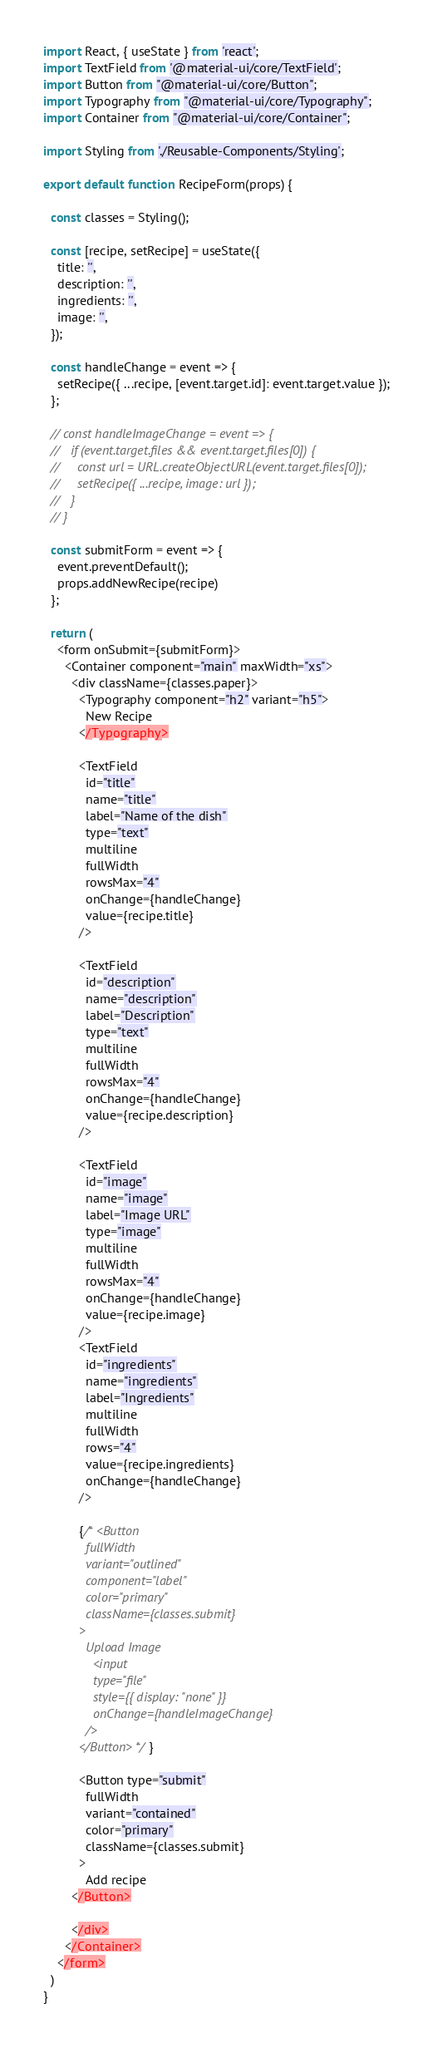Convert code to text. <code><loc_0><loc_0><loc_500><loc_500><_JavaScript_>import React, { useState } from 'react';
import TextField from '@material-ui/core/TextField';
import Button from "@material-ui/core/Button";
import Typography from "@material-ui/core/Typography";
import Container from "@material-ui/core/Container";

import Styling from './Reusable-Components/Styling';

export default function RecipeForm(props) {

  const classes = Styling();

  const [recipe, setRecipe] = useState({
    title: '',
    description: '',
    ingredients: '',
    image: '',
  });

  const handleChange = event => {
    setRecipe({ ...recipe, [event.target.id]: event.target.value });
  };

  // const handleImageChange = event => {
  //   if (event.target.files && event.target.files[0]) {
  //     const url = URL.createObjectURL(event.target.files[0]);
  //     setRecipe({ ...recipe, image: url });
  //   }
  // }

  const submitForm = event => {
    event.preventDefault();
    props.addNewRecipe(recipe)
  };

  return (
    <form onSubmit={submitForm}>
      <Container component="main" maxWidth="xs">
        <div className={classes.paper}>
          <Typography component="h2" variant="h5">
            New Recipe
          </Typography>

          <TextField
            id="title"
            name="title"
            label="Name of the dish"
            type="text"
            multiline
            fullWidth
            rowsMax="4"
            onChange={handleChange}
            value={recipe.title}
          />

          <TextField
            id="description"
            name="description"
            label="Description"
            type="text"
            multiline
            fullWidth
            rowsMax="4"
            onChange={handleChange}
            value={recipe.description}
          />

          <TextField
            id="image"
            name="image"
            label="Image URL"
            type="image"
            multiline
            fullWidth
            rowsMax="4"
            onChange={handleChange}
            value={recipe.image}
          />
          <TextField
            id="ingredients"
            name="ingredients"
            label="Ingredients"
            multiline
            fullWidth
            rows="4"
            value={recipe.ingredients}
            onChange={handleChange}
          />

          {/* <Button
            fullWidth
            variant="outlined"
            component="label"
            color="primary"
            className={classes.submit}
          >
            Upload Image
              <input
              type="file"
              style={{ display: "none" }}
              onChange={handleImageChange}
            />
          </Button> */}

          <Button type="submit"
            fullWidth
            variant="contained"
            color="primary"
            className={classes.submit}
          >
            Add recipe
        </Button>

        </div>
      </Container>
    </form>
  )
}</code> 